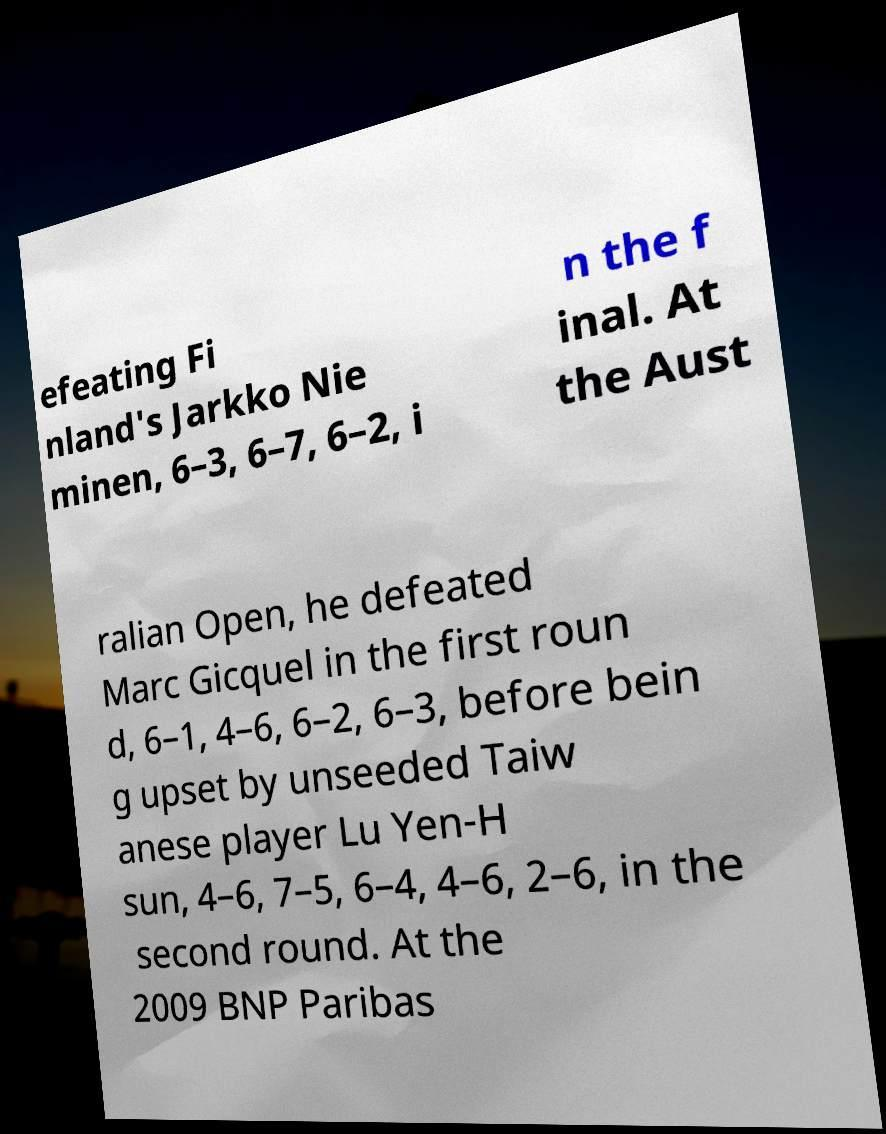For documentation purposes, I need the text within this image transcribed. Could you provide that? efeating Fi nland's Jarkko Nie minen, 6–3, 6–7, 6–2, i n the f inal. At the Aust ralian Open, he defeated Marc Gicquel in the first roun d, 6–1, 4–6, 6–2, 6–3, before bein g upset by unseeded Taiw anese player Lu Yen-H sun, 4–6, 7–5, 6–4, 4–6, 2–6, in the second round. At the 2009 BNP Paribas 